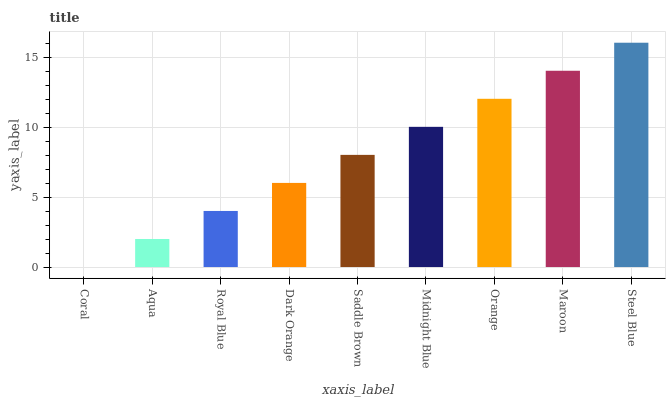Is Coral the minimum?
Answer yes or no. Yes. Is Steel Blue the maximum?
Answer yes or no. Yes. Is Aqua the minimum?
Answer yes or no. No. Is Aqua the maximum?
Answer yes or no. No. Is Aqua greater than Coral?
Answer yes or no. Yes. Is Coral less than Aqua?
Answer yes or no. Yes. Is Coral greater than Aqua?
Answer yes or no. No. Is Aqua less than Coral?
Answer yes or no. No. Is Saddle Brown the high median?
Answer yes or no. Yes. Is Saddle Brown the low median?
Answer yes or no. Yes. Is Midnight Blue the high median?
Answer yes or no. No. Is Aqua the low median?
Answer yes or no. No. 